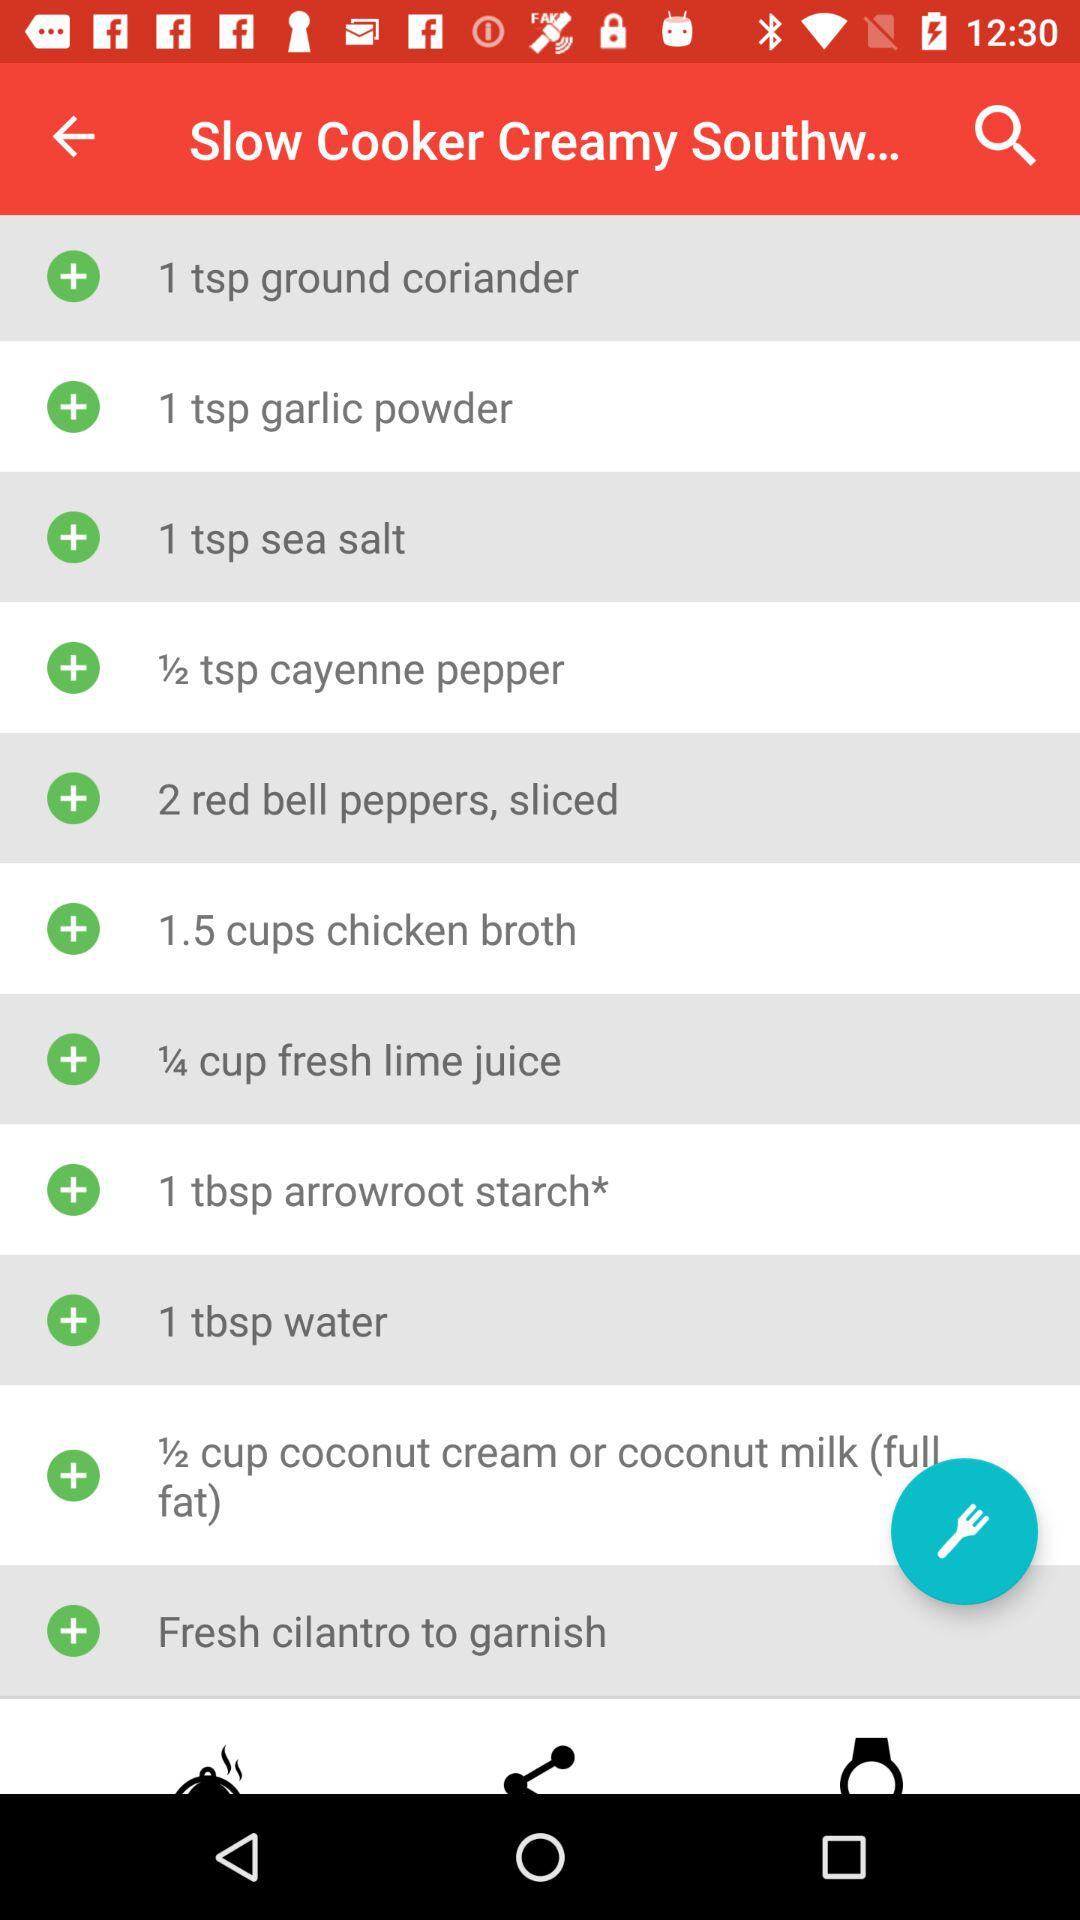What is used for garnishing? For garnishing, fresh cilantro is used. 